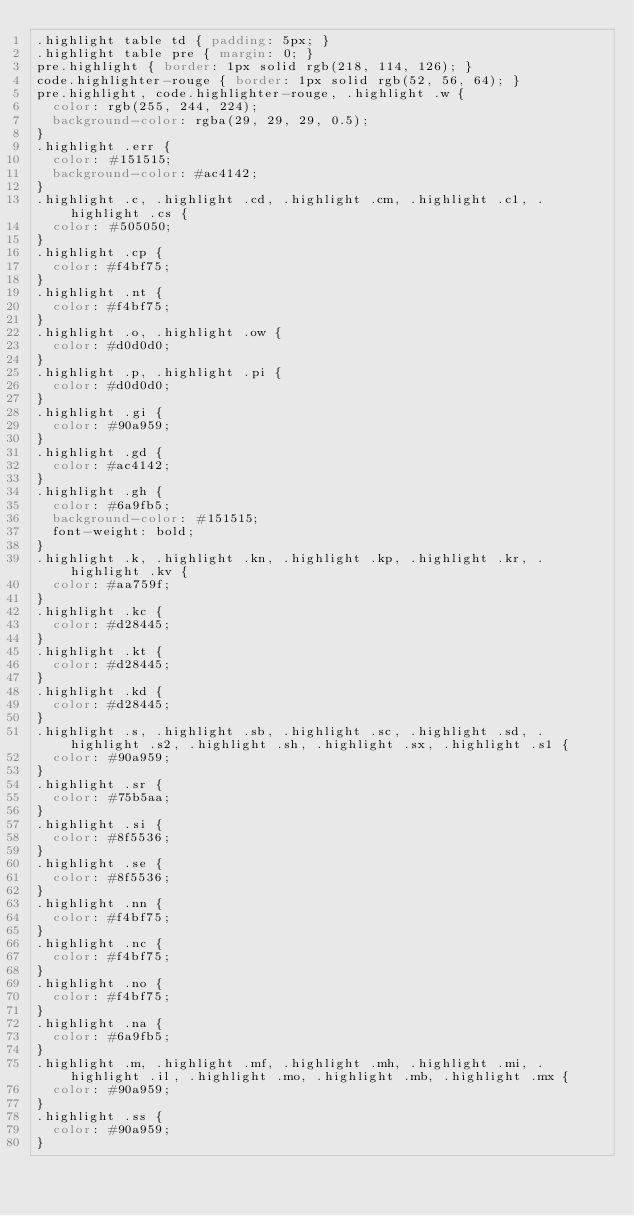<code> <loc_0><loc_0><loc_500><loc_500><_CSS_>.highlight table td { padding: 5px; }
.highlight table pre { margin: 0; }
pre.highlight { border: 1px solid rgb(218, 114, 126); }
code.highlighter-rouge { border: 1px solid rgb(52, 56, 64); }
pre.highlight, code.highlighter-rouge, .highlight .w {
  color: rgb(255, 244, 224);
  background-color: rgba(29, 29, 29, 0.5);
}
.highlight .err {
  color: #151515;
  background-color: #ac4142;
}
.highlight .c, .highlight .cd, .highlight .cm, .highlight .c1, .highlight .cs {
  color: #505050;
}
.highlight .cp {
  color: #f4bf75;
}
.highlight .nt {
  color: #f4bf75;
}
.highlight .o, .highlight .ow {
  color: #d0d0d0;
}
.highlight .p, .highlight .pi {
  color: #d0d0d0;
}
.highlight .gi {
  color: #90a959;
}
.highlight .gd {
  color: #ac4142;
}
.highlight .gh {
  color: #6a9fb5;
  background-color: #151515;
  font-weight: bold;
}
.highlight .k, .highlight .kn, .highlight .kp, .highlight .kr, .highlight .kv {
  color: #aa759f;
}
.highlight .kc {
  color: #d28445;
}
.highlight .kt {
  color: #d28445;
}
.highlight .kd {
  color: #d28445;
}
.highlight .s, .highlight .sb, .highlight .sc, .highlight .sd, .highlight .s2, .highlight .sh, .highlight .sx, .highlight .s1 {
  color: #90a959;
}
.highlight .sr {
  color: #75b5aa;
}
.highlight .si {
  color: #8f5536;
}
.highlight .se {
  color: #8f5536;
}
.highlight .nn {
  color: #f4bf75;
}
.highlight .nc {
  color: #f4bf75;
}
.highlight .no {
  color: #f4bf75;
}
.highlight .na {
  color: #6a9fb5;
}
.highlight .m, .highlight .mf, .highlight .mh, .highlight .mi, .highlight .il, .highlight .mo, .highlight .mb, .highlight .mx {
  color: #90a959;
}
.highlight .ss {
  color: #90a959;
}
</code> 